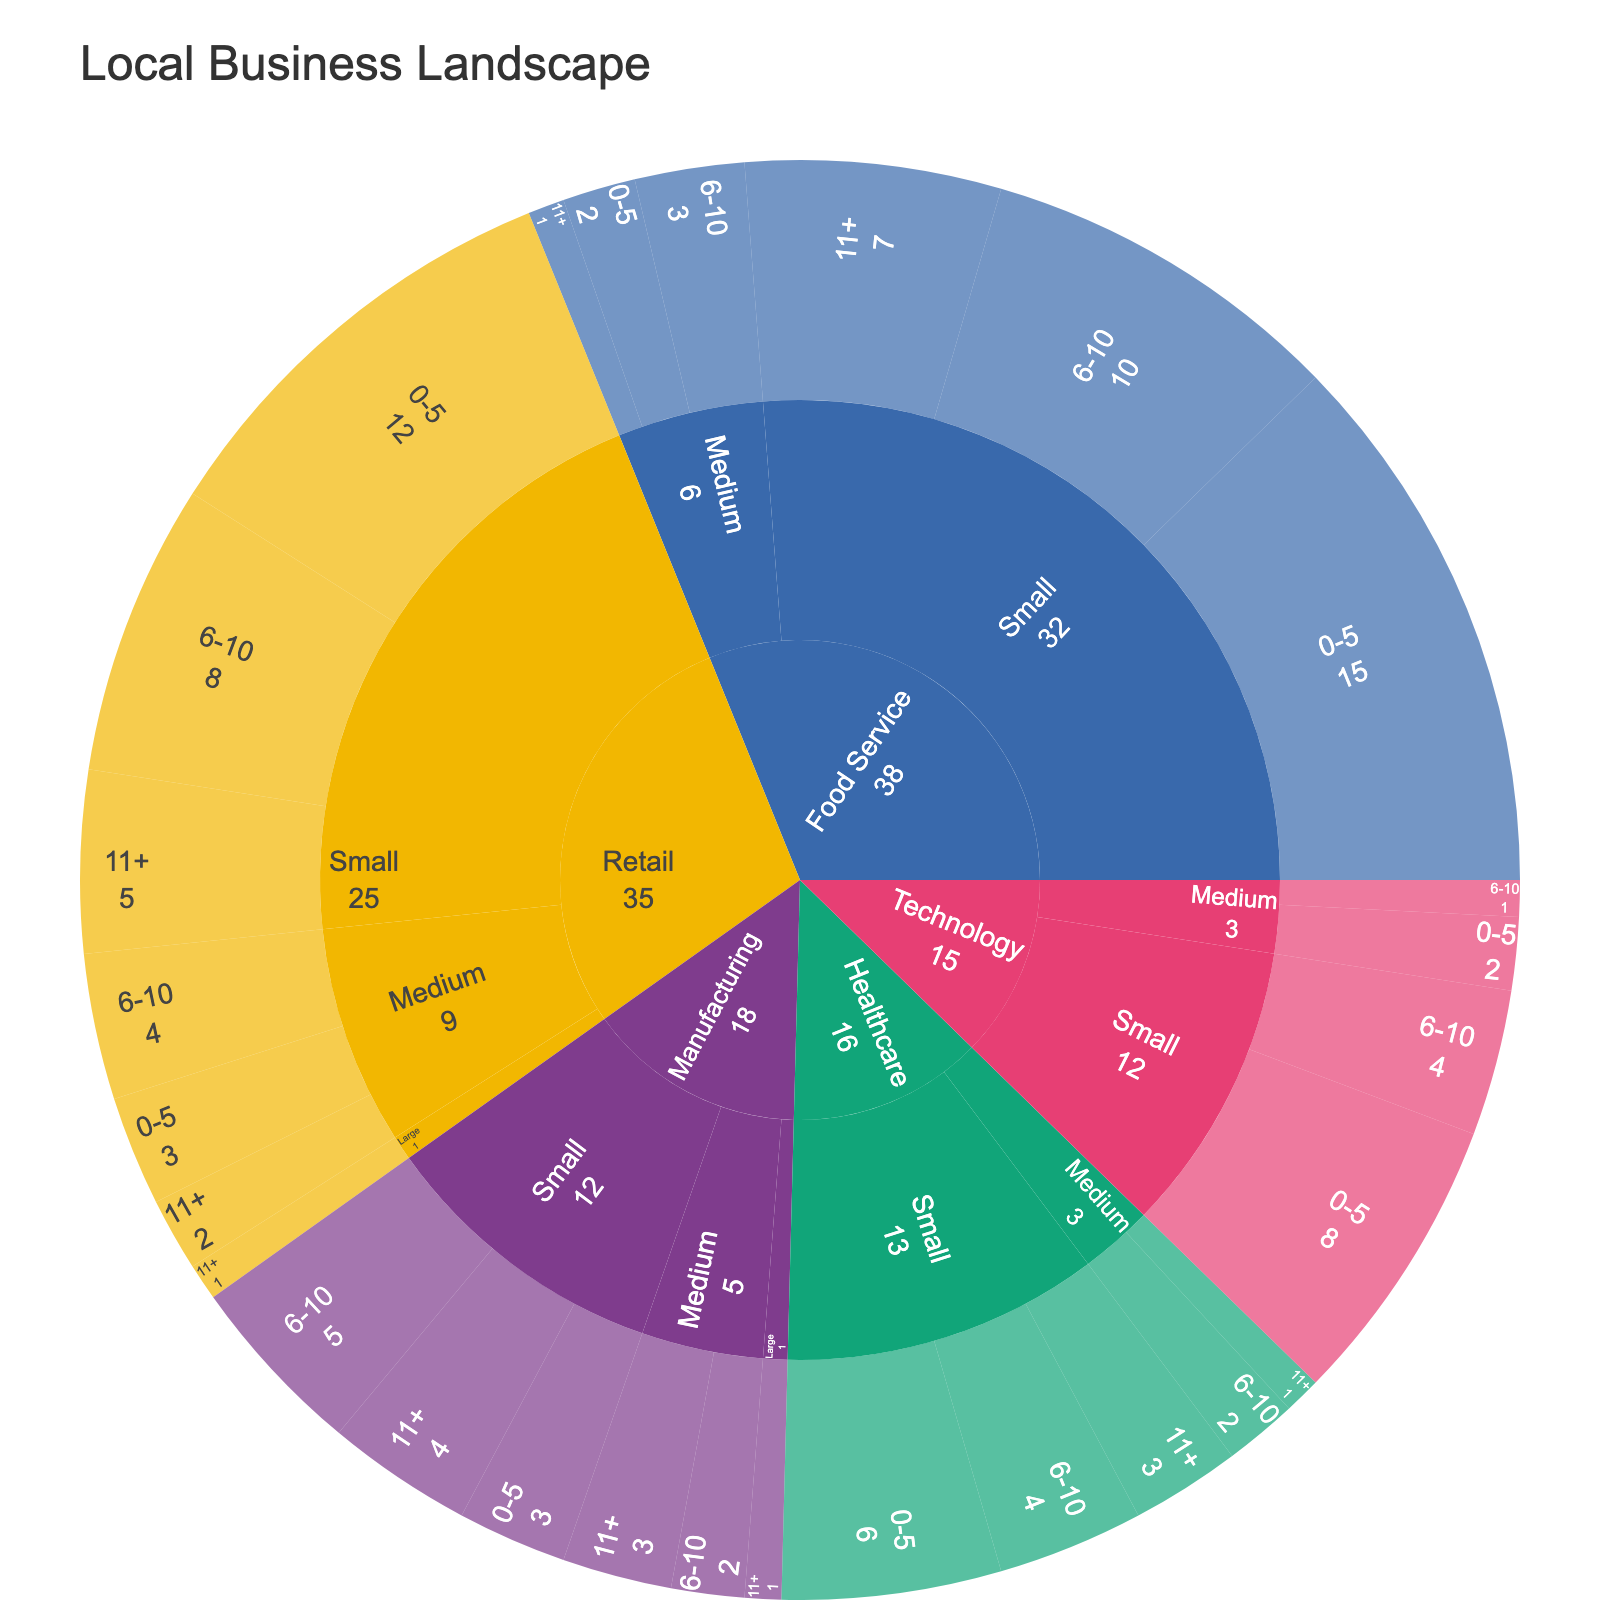What is the title of the plot? The title of the plot is usually located at the top of the figure. Reading directly from here, we see the title of the plot is "Local Business Landscape".
Answer: Local Business Landscape How many nodes are there in the Food Service industry? To count the nodes in the Food Service industry, we identify all the different categories under Food Service. There are nodes for Small (0-5, 6-10, 11+ years) and Medium (0-5, 6-10, 11+ years). This results in 6 nodes.
Answer: 6 Which industry has the highest number of small businesses that have been operating for 0-5 years? Each industry's node for small businesses operating for 0-5 years should be examined. Retail has 12, Food Service has 15, Technology has 8, Manufacturing has 3, and Healthcare has 6. The highest number is in Food Service with 15 businesses.
Answer: Food Service How many large businesses are there in total? To find this, sum the counts of all large businesses across the industries. Retail has 1, and Manufacturing has 1, resulting in a total of 2 large businesses.
Answer: 2 Which category has more small businesses, Retail or Food Service? Compare the totals for small businesses in Retail (12 + 8 + 5 = 25) and Food Service (15 + 10 + 7 = 32). Food Service has more small businesses.
Answer: Food Service Which industry shows the most businesses operating for 11+ years across all sizes? Sum the counts of businesses operating for 11+ years in each industry: Retail (5 + 2 + 1 = 8), Food Service (7 + 1 = 8), Technology (0), Manufacturing (4 + 3 + 1 = 8), Healthcare (3 + 1 = 4). Retail, Food Service, and Manufacturing each have 8.
Answer: Retail, Food Service, and Manufacturing What is the total number of businesses in the Technology industry? Add all the counts in the Technology category: 8 (0-5) + 4 (6-10) + 2 (0-5) + 1 (6-10) = 15.
Answer: 15 What is the ratio of small to medium businesses in the Healthcare industry? Count the total small businesses: 6 (0-5) + 4 (6-10) + 3 (11+) = 13. Count the total medium businesses: 2 (6-10) + 1 (11+) = 3. The ratio of small to medium is 13 : 3.
Answer: 13:3 Which industry has the smallest number of medium-sized businesses? Check the medium-sized businesses count in each industry: Retail (3 + 4 + 2 = 9), Food Service (2 + 3 + 1 = 6), Technology (2 + 1 = 3), Manufacturing (2 + 3 = 5), Healthcare (2 + 1 = 3). Technology and Healthcare both have the smallest, with 3 medium businesses each.
Answer: Technology and Healthcare 